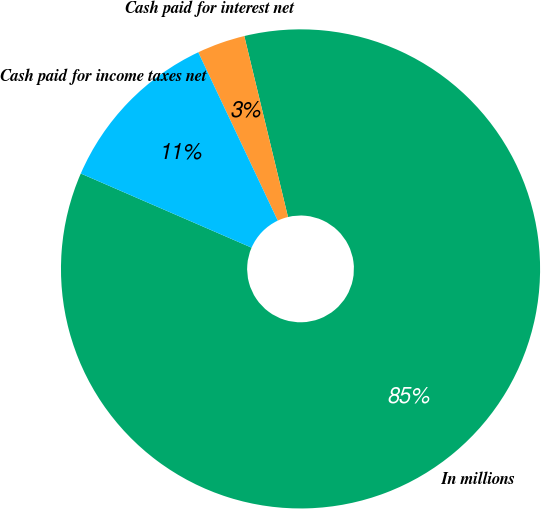Convert chart. <chart><loc_0><loc_0><loc_500><loc_500><pie_chart><fcel>In millions<fcel>Cash paid for interest net<fcel>Cash paid for income taxes net<nl><fcel>85.29%<fcel>3.25%<fcel>11.46%<nl></chart> 